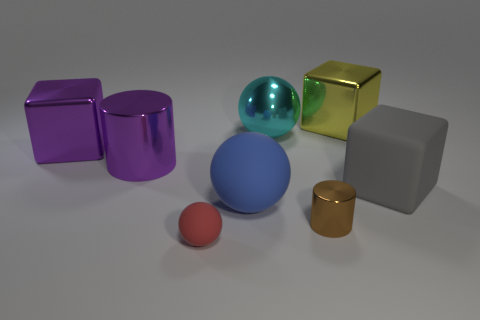Which object stands out the most to you and why? The large cyan sphere stands out the most due to its vibrant color, which contrasts with the more muted tones of the other objects. Additionally, the sphere's size relative to the other shapes draws the eye, making it a focal point in the composition. 